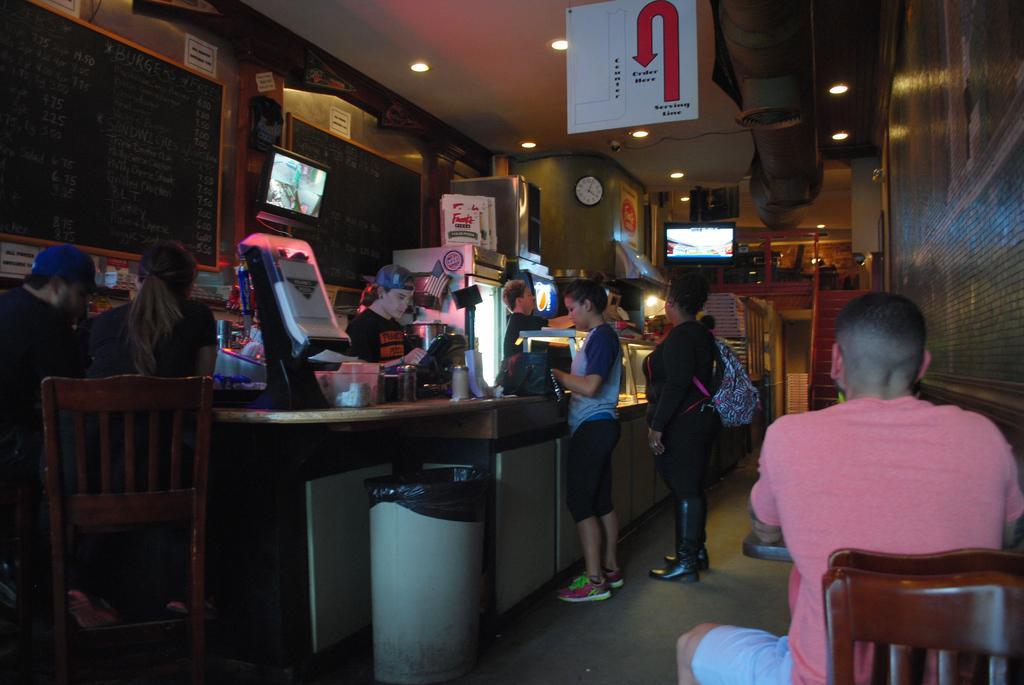In one or two sentences, can you explain what this image depicts? As we can see in the image there is a wall, clock, screen, board, and few people standing and sitting on chairs. 